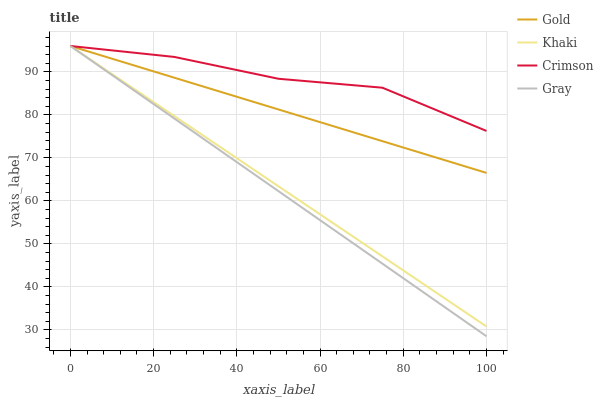Does Gray have the minimum area under the curve?
Answer yes or no. Yes. Does Crimson have the maximum area under the curve?
Answer yes or no. Yes. Does Khaki have the minimum area under the curve?
Answer yes or no. No. Does Khaki have the maximum area under the curve?
Answer yes or no. No. Is Khaki the smoothest?
Answer yes or no. Yes. Is Crimson the roughest?
Answer yes or no. Yes. Is Gray the smoothest?
Answer yes or no. No. Is Gray the roughest?
Answer yes or no. No. Does Gray have the lowest value?
Answer yes or no. Yes. Does Khaki have the lowest value?
Answer yes or no. No. Does Gold have the highest value?
Answer yes or no. Yes. Does Crimson intersect Gold?
Answer yes or no. Yes. Is Crimson less than Gold?
Answer yes or no. No. Is Crimson greater than Gold?
Answer yes or no. No. 